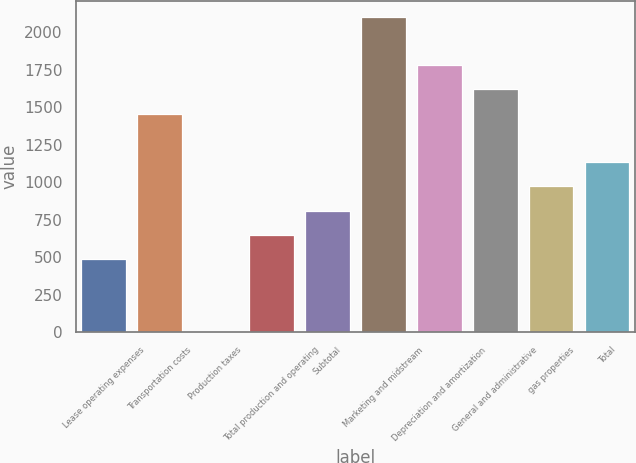Convert chart. <chart><loc_0><loc_0><loc_500><loc_500><bar_chart><fcel>Lease operating expenses<fcel>Transportation costs<fcel>Production taxes<fcel>Total production and operating<fcel>Subtotal<fcel>Marketing and midstream<fcel>Depreciation and amortization<fcel>General and administrative<fcel>gas properties<fcel>Total<nl><fcel>488.5<fcel>1457.5<fcel>4<fcel>650<fcel>811.5<fcel>2103.5<fcel>1780.5<fcel>1619<fcel>973<fcel>1134.5<nl></chart> 